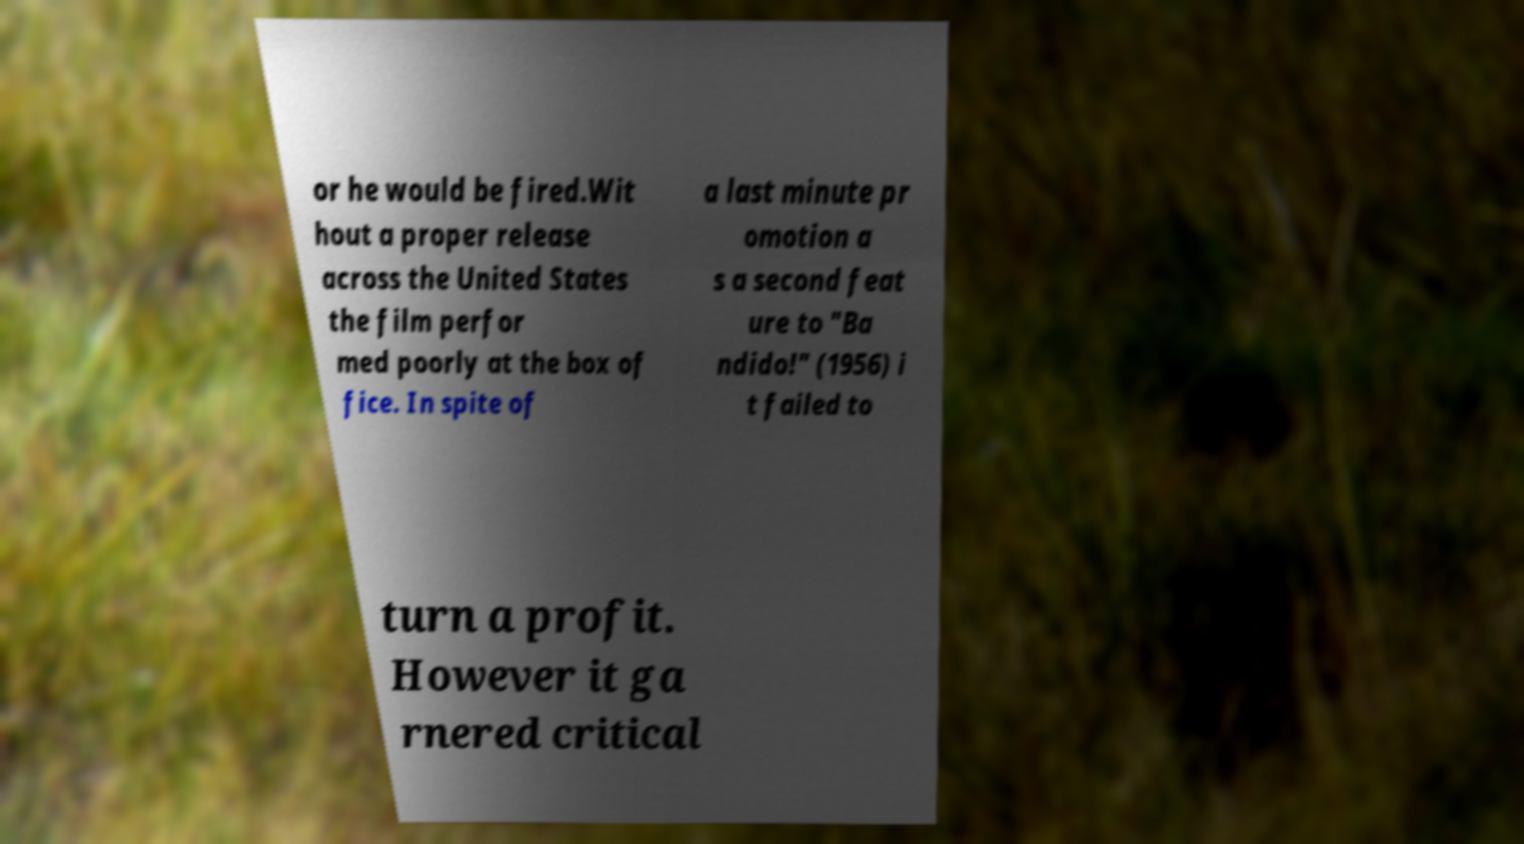For documentation purposes, I need the text within this image transcribed. Could you provide that? or he would be fired.Wit hout a proper release across the United States the film perfor med poorly at the box of fice. In spite of a last minute pr omotion a s a second feat ure to "Ba ndido!" (1956) i t failed to turn a profit. However it ga rnered critical 